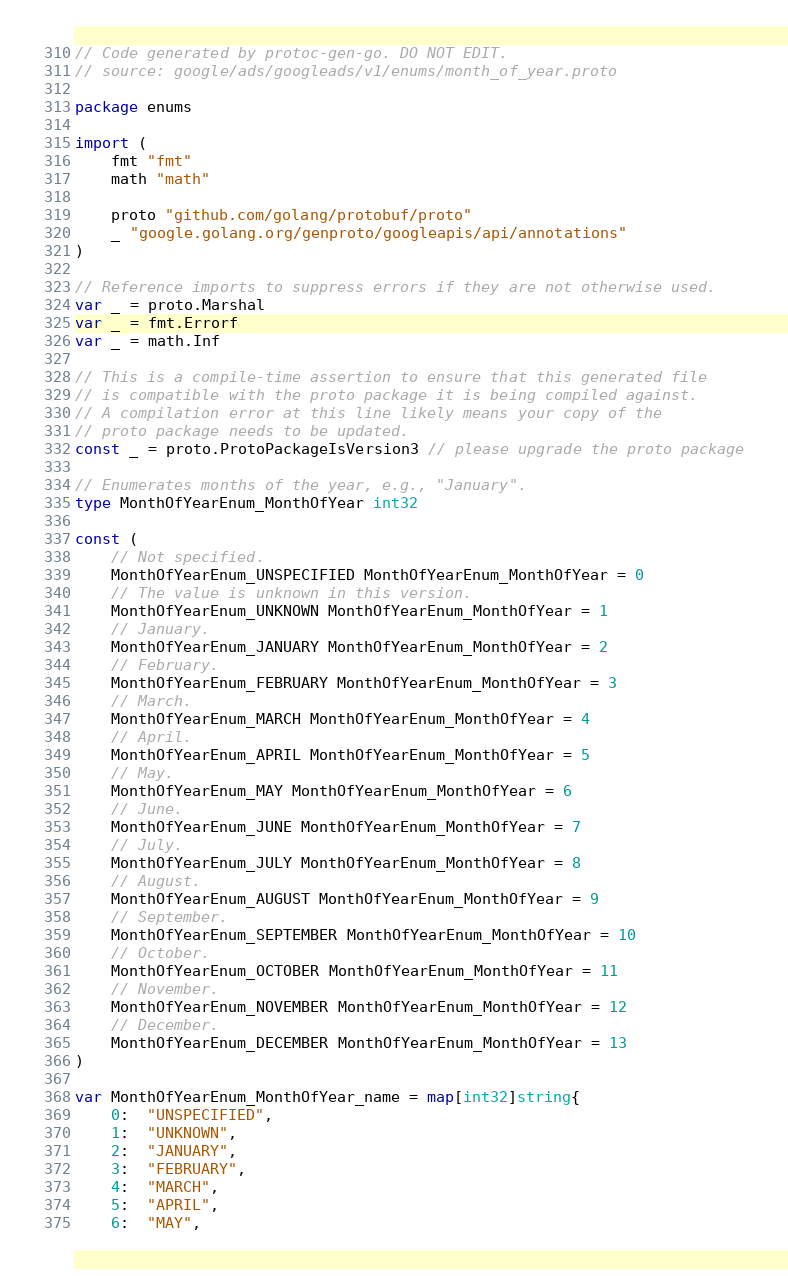<code> <loc_0><loc_0><loc_500><loc_500><_Go_>// Code generated by protoc-gen-go. DO NOT EDIT.
// source: google/ads/googleads/v1/enums/month_of_year.proto

package enums

import (
	fmt "fmt"
	math "math"

	proto "github.com/golang/protobuf/proto"
	_ "google.golang.org/genproto/googleapis/api/annotations"
)

// Reference imports to suppress errors if they are not otherwise used.
var _ = proto.Marshal
var _ = fmt.Errorf
var _ = math.Inf

// This is a compile-time assertion to ensure that this generated file
// is compatible with the proto package it is being compiled against.
// A compilation error at this line likely means your copy of the
// proto package needs to be updated.
const _ = proto.ProtoPackageIsVersion3 // please upgrade the proto package

// Enumerates months of the year, e.g., "January".
type MonthOfYearEnum_MonthOfYear int32

const (
	// Not specified.
	MonthOfYearEnum_UNSPECIFIED MonthOfYearEnum_MonthOfYear = 0
	// The value is unknown in this version.
	MonthOfYearEnum_UNKNOWN MonthOfYearEnum_MonthOfYear = 1
	// January.
	MonthOfYearEnum_JANUARY MonthOfYearEnum_MonthOfYear = 2
	// February.
	MonthOfYearEnum_FEBRUARY MonthOfYearEnum_MonthOfYear = 3
	// March.
	MonthOfYearEnum_MARCH MonthOfYearEnum_MonthOfYear = 4
	// April.
	MonthOfYearEnum_APRIL MonthOfYearEnum_MonthOfYear = 5
	// May.
	MonthOfYearEnum_MAY MonthOfYearEnum_MonthOfYear = 6
	// June.
	MonthOfYearEnum_JUNE MonthOfYearEnum_MonthOfYear = 7
	// July.
	MonthOfYearEnum_JULY MonthOfYearEnum_MonthOfYear = 8
	// August.
	MonthOfYearEnum_AUGUST MonthOfYearEnum_MonthOfYear = 9
	// September.
	MonthOfYearEnum_SEPTEMBER MonthOfYearEnum_MonthOfYear = 10
	// October.
	MonthOfYearEnum_OCTOBER MonthOfYearEnum_MonthOfYear = 11
	// November.
	MonthOfYearEnum_NOVEMBER MonthOfYearEnum_MonthOfYear = 12
	// December.
	MonthOfYearEnum_DECEMBER MonthOfYearEnum_MonthOfYear = 13
)

var MonthOfYearEnum_MonthOfYear_name = map[int32]string{
	0:  "UNSPECIFIED",
	1:  "UNKNOWN",
	2:  "JANUARY",
	3:  "FEBRUARY",
	4:  "MARCH",
	5:  "APRIL",
	6:  "MAY",</code> 